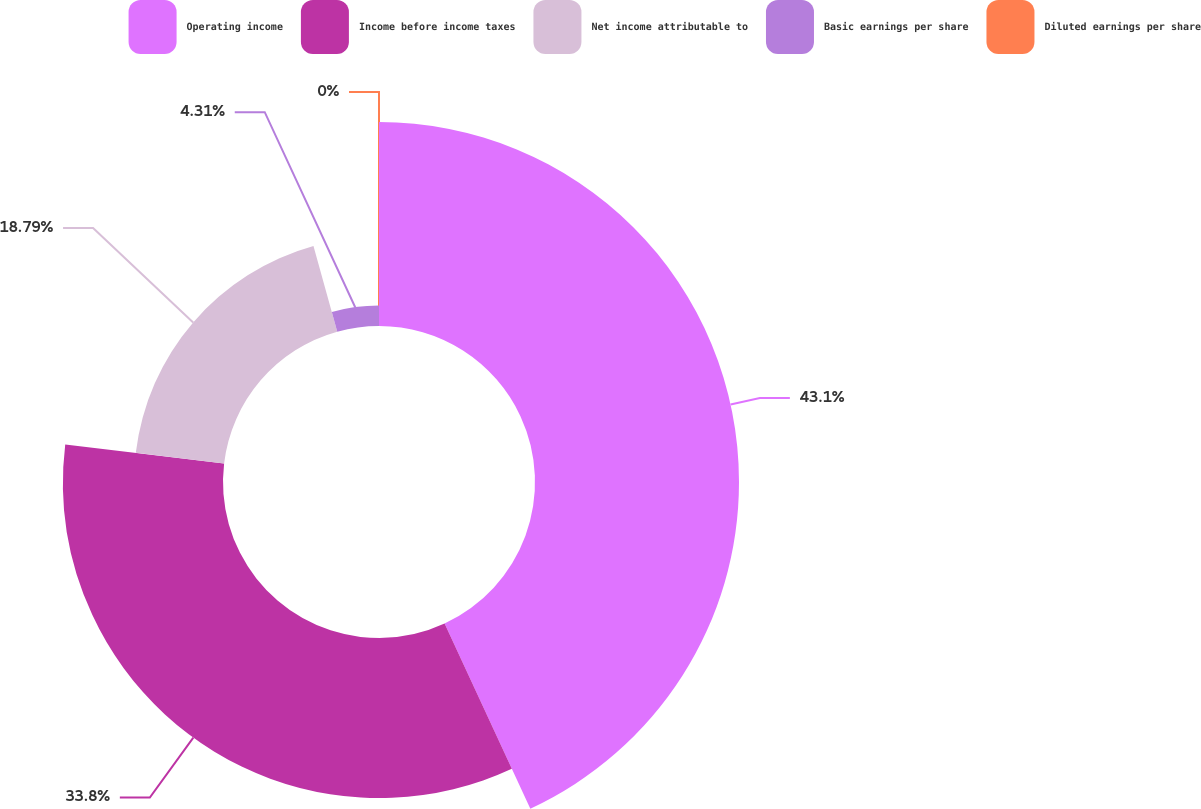Convert chart. <chart><loc_0><loc_0><loc_500><loc_500><pie_chart><fcel>Operating income<fcel>Income before income taxes<fcel>Net income attributable to<fcel>Basic earnings per share<fcel>Diluted earnings per share<nl><fcel>43.09%<fcel>33.8%<fcel>18.79%<fcel>4.31%<fcel>0.0%<nl></chart> 